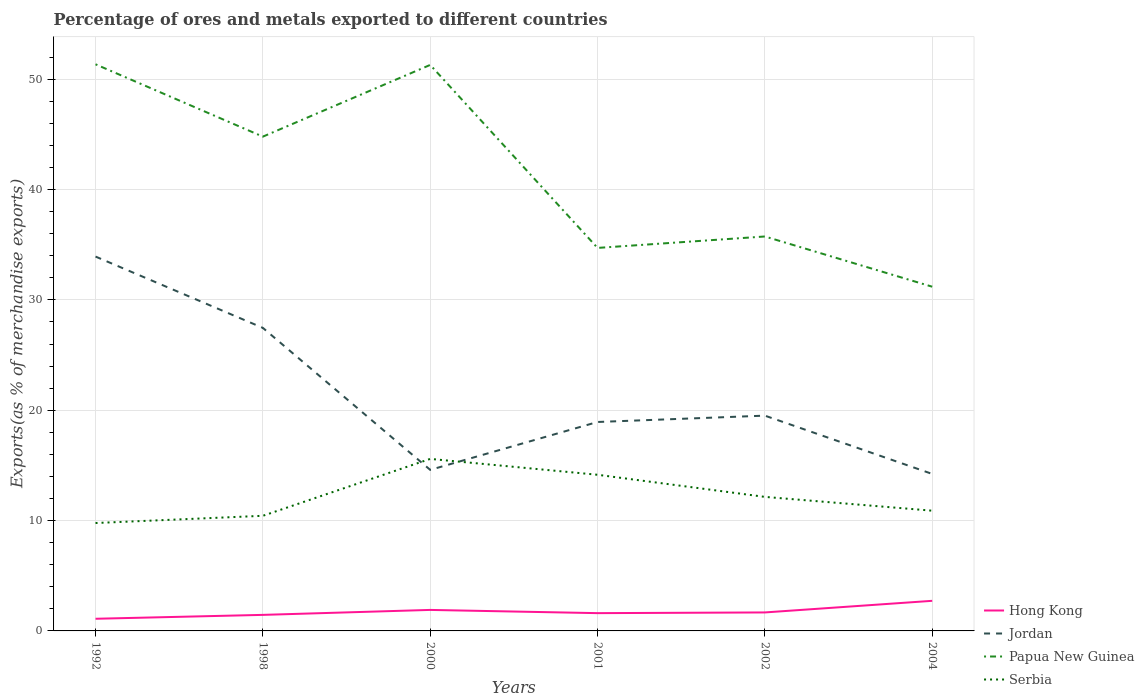How many different coloured lines are there?
Provide a short and direct response. 4. Across all years, what is the maximum percentage of exports to different countries in Papua New Guinea?
Keep it short and to the point. 31.2. In which year was the percentage of exports to different countries in Hong Kong maximum?
Offer a very short reply. 1992. What is the total percentage of exports to different countries in Jordan in the graph?
Offer a very short reply. 0.37. What is the difference between the highest and the second highest percentage of exports to different countries in Jordan?
Your response must be concise. 19.7. What is the difference between the highest and the lowest percentage of exports to different countries in Papua New Guinea?
Offer a very short reply. 3. How many lines are there?
Give a very brief answer. 4. Are the values on the major ticks of Y-axis written in scientific E-notation?
Make the answer very short. No. Does the graph contain any zero values?
Make the answer very short. No. Does the graph contain grids?
Your response must be concise. Yes. Where does the legend appear in the graph?
Offer a very short reply. Bottom right. How are the legend labels stacked?
Make the answer very short. Vertical. What is the title of the graph?
Your response must be concise. Percentage of ores and metals exported to different countries. What is the label or title of the X-axis?
Ensure brevity in your answer.  Years. What is the label or title of the Y-axis?
Offer a terse response. Exports(as % of merchandise exports). What is the Exports(as % of merchandise exports) in Hong Kong in 1992?
Keep it short and to the point. 1.1. What is the Exports(as % of merchandise exports) of Jordan in 1992?
Offer a terse response. 33.93. What is the Exports(as % of merchandise exports) of Papua New Guinea in 1992?
Offer a terse response. 51.36. What is the Exports(as % of merchandise exports) in Serbia in 1992?
Your answer should be compact. 9.78. What is the Exports(as % of merchandise exports) in Hong Kong in 1998?
Your response must be concise. 1.45. What is the Exports(as % of merchandise exports) of Jordan in 1998?
Your response must be concise. 27.46. What is the Exports(as % of merchandise exports) of Papua New Guinea in 1998?
Offer a terse response. 44.8. What is the Exports(as % of merchandise exports) in Serbia in 1998?
Keep it short and to the point. 10.43. What is the Exports(as % of merchandise exports) in Hong Kong in 2000?
Provide a succinct answer. 1.9. What is the Exports(as % of merchandise exports) in Jordan in 2000?
Keep it short and to the point. 14.6. What is the Exports(as % of merchandise exports) in Papua New Guinea in 2000?
Provide a short and direct response. 51.3. What is the Exports(as % of merchandise exports) in Serbia in 2000?
Your response must be concise. 15.59. What is the Exports(as % of merchandise exports) of Hong Kong in 2001?
Your answer should be compact. 1.61. What is the Exports(as % of merchandise exports) of Jordan in 2001?
Offer a very short reply. 18.94. What is the Exports(as % of merchandise exports) of Papua New Guinea in 2001?
Give a very brief answer. 34.71. What is the Exports(as % of merchandise exports) in Serbia in 2001?
Provide a short and direct response. 14.15. What is the Exports(as % of merchandise exports) in Hong Kong in 2002?
Keep it short and to the point. 1.67. What is the Exports(as % of merchandise exports) of Jordan in 2002?
Your answer should be compact. 19.51. What is the Exports(as % of merchandise exports) of Papua New Guinea in 2002?
Provide a short and direct response. 35.75. What is the Exports(as % of merchandise exports) in Serbia in 2002?
Make the answer very short. 12.15. What is the Exports(as % of merchandise exports) of Hong Kong in 2004?
Your answer should be compact. 2.73. What is the Exports(as % of merchandise exports) of Jordan in 2004?
Ensure brevity in your answer.  14.23. What is the Exports(as % of merchandise exports) of Papua New Guinea in 2004?
Make the answer very short. 31.2. What is the Exports(as % of merchandise exports) in Serbia in 2004?
Your answer should be compact. 10.9. Across all years, what is the maximum Exports(as % of merchandise exports) of Hong Kong?
Offer a terse response. 2.73. Across all years, what is the maximum Exports(as % of merchandise exports) in Jordan?
Provide a succinct answer. 33.93. Across all years, what is the maximum Exports(as % of merchandise exports) of Papua New Guinea?
Keep it short and to the point. 51.36. Across all years, what is the maximum Exports(as % of merchandise exports) in Serbia?
Offer a terse response. 15.59. Across all years, what is the minimum Exports(as % of merchandise exports) of Hong Kong?
Make the answer very short. 1.1. Across all years, what is the minimum Exports(as % of merchandise exports) of Jordan?
Keep it short and to the point. 14.23. Across all years, what is the minimum Exports(as % of merchandise exports) of Papua New Guinea?
Provide a succinct answer. 31.2. Across all years, what is the minimum Exports(as % of merchandise exports) of Serbia?
Ensure brevity in your answer.  9.78. What is the total Exports(as % of merchandise exports) in Hong Kong in the graph?
Your response must be concise. 10.47. What is the total Exports(as % of merchandise exports) of Jordan in the graph?
Give a very brief answer. 128.67. What is the total Exports(as % of merchandise exports) of Papua New Guinea in the graph?
Your response must be concise. 249.11. What is the total Exports(as % of merchandise exports) of Serbia in the graph?
Your answer should be compact. 73. What is the difference between the Exports(as % of merchandise exports) of Hong Kong in 1992 and that in 1998?
Make the answer very short. -0.35. What is the difference between the Exports(as % of merchandise exports) in Jordan in 1992 and that in 1998?
Your answer should be compact. 6.46. What is the difference between the Exports(as % of merchandise exports) of Papua New Guinea in 1992 and that in 1998?
Your response must be concise. 6.56. What is the difference between the Exports(as % of merchandise exports) in Serbia in 1992 and that in 1998?
Provide a short and direct response. -0.66. What is the difference between the Exports(as % of merchandise exports) of Hong Kong in 1992 and that in 2000?
Make the answer very short. -0.8. What is the difference between the Exports(as % of merchandise exports) of Jordan in 1992 and that in 2000?
Your answer should be compact. 19.33. What is the difference between the Exports(as % of merchandise exports) of Papua New Guinea in 1992 and that in 2000?
Offer a terse response. 0.06. What is the difference between the Exports(as % of merchandise exports) of Serbia in 1992 and that in 2000?
Offer a very short reply. -5.81. What is the difference between the Exports(as % of merchandise exports) in Hong Kong in 1992 and that in 2001?
Your answer should be very brief. -0.51. What is the difference between the Exports(as % of merchandise exports) in Jordan in 1992 and that in 2001?
Give a very brief answer. 14.99. What is the difference between the Exports(as % of merchandise exports) in Papua New Guinea in 1992 and that in 2001?
Make the answer very short. 16.64. What is the difference between the Exports(as % of merchandise exports) in Serbia in 1992 and that in 2001?
Your response must be concise. -4.37. What is the difference between the Exports(as % of merchandise exports) of Hong Kong in 1992 and that in 2002?
Your response must be concise. -0.57. What is the difference between the Exports(as % of merchandise exports) in Jordan in 1992 and that in 2002?
Your answer should be compact. 14.42. What is the difference between the Exports(as % of merchandise exports) of Papua New Guinea in 1992 and that in 2002?
Make the answer very short. 15.61. What is the difference between the Exports(as % of merchandise exports) in Serbia in 1992 and that in 2002?
Offer a very short reply. -2.37. What is the difference between the Exports(as % of merchandise exports) in Hong Kong in 1992 and that in 2004?
Keep it short and to the point. -1.63. What is the difference between the Exports(as % of merchandise exports) in Jordan in 1992 and that in 2004?
Give a very brief answer. 19.7. What is the difference between the Exports(as % of merchandise exports) of Papua New Guinea in 1992 and that in 2004?
Make the answer very short. 20.16. What is the difference between the Exports(as % of merchandise exports) in Serbia in 1992 and that in 2004?
Your answer should be compact. -1.12. What is the difference between the Exports(as % of merchandise exports) in Hong Kong in 1998 and that in 2000?
Give a very brief answer. -0.45. What is the difference between the Exports(as % of merchandise exports) in Jordan in 1998 and that in 2000?
Ensure brevity in your answer.  12.87. What is the difference between the Exports(as % of merchandise exports) of Papua New Guinea in 1998 and that in 2000?
Provide a succinct answer. -6.5. What is the difference between the Exports(as % of merchandise exports) of Serbia in 1998 and that in 2000?
Offer a very short reply. -5.16. What is the difference between the Exports(as % of merchandise exports) in Hong Kong in 1998 and that in 2001?
Give a very brief answer. -0.16. What is the difference between the Exports(as % of merchandise exports) in Jordan in 1998 and that in 2001?
Provide a succinct answer. 8.53. What is the difference between the Exports(as % of merchandise exports) of Papua New Guinea in 1998 and that in 2001?
Offer a terse response. 10.09. What is the difference between the Exports(as % of merchandise exports) in Serbia in 1998 and that in 2001?
Your answer should be compact. -3.72. What is the difference between the Exports(as % of merchandise exports) of Hong Kong in 1998 and that in 2002?
Make the answer very short. -0.22. What is the difference between the Exports(as % of merchandise exports) in Jordan in 1998 and that in 2002?
Provide a succinct answer. 7.95. What is the difference between the Exports(as % of merchandise exports) in Papua New Guinea in 1998 and that in 2002?
Provide a short and direct response. 9.05. What is the difference between the Exports(as % of merchandise exports) of Serbia in 1998 and that in 2002?
Keep it short and to the point. -1.71. What is the difference between the Exports(as % of merchandise exports) of Hong Kong in 1998 and that in 2004?
Your answer should be compact. -1.27. What is the difference between the Exports(as % of merchandise exports) in Jordan in 1998 and that in 2004?
Your answer should be very brief. 13.24. What is the difference between the Exports(as % of merchandise exports) in Papua New Guinea in 1998 and that in 2004?
Your answer should be compact. 13.6. What is the difference between the Exports(as % of merchandise exports) in Serbia in 1998 and that in 2004?
Make the answer very short. -0.46. What is the difference between the Exports(as % of merchandise exports) of Hong Kong in 2000 and that in 2001?
Make the answer very short. 0.29. What is the difference between the Exports(as % of merchandise exports) in Jordan in 2000 and that in 2001?
Your response must be concise. -4.34. What is the difference between the Exports(as % of merchandise exports) of Papua New Guinea in 2000 and that in 2001?
Provide a short and direct response. 16.59. What is the difference between the Exports(as % of merchandise exports) of Serbia in 2000 and that in 2001?
Offer a terse response. 1.44. What is the difference between the Exports(as % of merchandise exports) of Hong Kong in 2000 and that in 2002?
Give a very brief answer. 0.23. What is the difference between the Exports(as % of merchandise exports) in Jordan in 2000 and that in 2002?
Offer a very short reply. -4.91. What is the difference between the Exports(as % of merchandise exports) in Papua New Guinea in 2000 and that in 2002?
Offer a terse response. 15.55. What is the difference between the Exports(as % of merchandise exports) of Serbia in 2000 and that in 2002?
Keep it short and to the point. 3.44. What is the difference between the Exports(as % of merchandise exports) of Hong Kong in 2000 and that in 2004?
Your response must be concise. -0.82. What is the difference between the Exports(as % of merchandise exports) of Jordan in 2000 and that in 2004?
Provide a short and direct response. 0.37. What is the difference between the Exports(as % of merchandise exports) in Papua New Guinea in 2000 and that in 2004?
Give a very brief answer. 20.1. What is the difference between the Exports(as % of merchandise exports) of Serbia in 2000 and that in 2004?
Ensure brevity in your answer.  4.69. What is the difference between the Exports(as % of merchandise exports) of Hong Kong in 2001 and that in 2002?
Provide a succinct answer. -0.06. What is the difference between the Exports(as % of merchandise exports) of Jordan in 2001 and that in 2002?
Ensure brevity in your answer.  -0.57. What is the difference between the Exports(as % of merchandise exports) of Papua New Guinea in 2001 and that in 2002?
Ensure brevity in your answer.  -1.04. What is the difference between the Exports(as % of merchandise exports) in Serbia in 2001 and that in 2002?
Keep it short and to the point. 2.01. What is the difference between the Exports(as % of merchandise exports) in Hong Kong in 2001 and that in 2004?
Make the answer very short. -1.12. What is the difference between the Exports(as % of merchandise exports) of Jordan in 2001 and that in 2004?
Offer a terse response. 4.71. What is the difference between the Exports(as % of merchandise exports) of Papua New Guinea in 2001 and that in 2004?
Your response must be concise. 3.52. What is the difference between the Exports(as % of merchandise exports) in Serbia in 2001 and that in 2004?
Give a very brief answer. 3.26. What is the difference between the Exports(as % of merchandise exports) of Hong Kong in 2002 and that in 2004?
Offer a very short reply. -1.05. What is the difference between the Exports(as % of merchandise exports) in Jordan in 2002 and that in 2004?
Give a very brief answer. 5.28. What is the difference between the Exports(as % of merchandise exports) of Papua New Guinea in 2002 and that in 2004?
Offer a terse response. 4.55. What is the difference between the Exports(as % of merchandise exports) in Serbia in 2002 and that in 2004?
Give a very brief answer. 1.25. What is the difference between the Exports(as % of merchandise exports) in Hong Kong in 1992 and the Exports(as % of merchandise exports) in Jordan in 1998?
Offer a terse response. -26.36. What is the difference between the Exports(as % of merchandise exports) of Hong Kong in 1992 and the Exports(as % of merchandise exports) of Papua New Guinea in 1998?
Make the answer very short. -43.7. What is the difference between the Exports(as % of merchandise exports) of Hong Kong in 1992 and the Exports(as % of merchandise exports) of Serbia in 1998?
Provide a succinct answer. -9.33. What is the difference between the Exports(as % of merchandise exports) of Jordan in 1992 and the Exports(as % of merchandise exports) of Papua New Guinea in 1998?
Your response must be concise. -10.87. What is the difference between the Exports(as % of merchandise exports) in Jordan in 1992 and the Exports(as % of merchandise exports) in Serbia in 1998?
Provide a short and direct response. 23.49. What is the difference between the Exports(as % of merchandise exports) in Papua New Guinea in 1992 and the Exports(as % of merchandise exports) in Serbia in 1998?
Provide a succinct answer. 40.92. What is the difference between the Exports(as % of merchandise exports) in Hong Kong in 1992 and the Exports(as % of merchandise exports) in Jordan in 2000?
Provide a short and direct response. -13.5. What is the difference between the Exports(as % of merchandise exports) in Hong Kong in 1992 and the Exports(as % of merchandise exports) in Papua New Guinea in 2000?
Provide a short and direct response. -50.2. What is the difference between the Exports(as % of merchandise exports) in Hong Kong in 1992 and the Exports(as % of merchandise exports) in Serbia in 2000?
Make the answer very short. -14.49. What is the difference between the Exports(as % of merchandise exports) in Jordan in 1992 and the Exports(as % of merchandise exports) in Papua New Guinea in 2000?
Provide a succinct answer. -17.37. What is the difference between the Exports(as % of merchandise exports) in Jordan in 1992 and the Exports(as % of merchandise exports) in Serbia in 2000?
Provide a short and direct response. 18.34. What is the difference between the Exports(as % of merchandise exports) in Papua New Guinea in 1992 and the Exports(as % of merchandise exports) in Serbia in 2000?
Your response must be concise. 35.76. What is the difference between the Exports(as % of merchandise exports) of Hong Kong in 1992 and the Exports(as % of merchandise exports) of Jordan in 2001?
Your answer should be compact. -17.83. What is the difference between the Exports(as % of merchandise exports) in Hong Kong in 1992 and the Exports(as % of merchandise exports) in Papua New Guinea in 2001?
Offer a very short reply. -33.61. What is the difference between the Exports(as % of merchandise exports) in Hong Kong in 1992 and the Exports(as % of merchandise exports) in Serbia in 2001?
Offer a terse response. -13.05. What is the difference between the Exports(as % of merchandise exports) of Jordan in 1992 and the Exports(as % of merchandise exports) of Papua New Guinea in 2001?
Ensure brevity in your answer.  -0.79. What is the difference between the Exports(as % of merchandise exports) in Jordan in 1992 and the Exports(as % of merchandise exports) in Serbia in 2001?
Provide a succinct answer. 19.78. What is the difference between the Exports(as % of merchandise exports) of Papua New Guinea in 1992 and the Exports(as % of merchandise exports) of Serbia in 2001?
Keep it short and to the point. 37.2. What is the difference between the Exports(as % of merchandise exports) in Hong Kong in 1992 and the Exports(as % of merchandise exports) in Jordan in 2002?
Your answer should be very brief. -18.41. What is the difference between the Exports(as % of merchandise exports) of Hong Kong in 1992 and the Exports(as % of merchandise exports) of Papua New Guinea in 2002?
Your response must be concise. -34.65. What is the difference between the Exports(as % of merchandise exports) in Hong Kong in 1992 and the Exports(as % of merchandise exports) in Serbia in 2002?
Make the answer very short. -11.05. What is the difference between the Exports(as % of merchandise exports) in Jordan in 1992 and the Exports(as % of merchandise exports) in Papua New Guinea in 2002?
Give a very brief answer. -1.82. What is the difference between the Exports(as % of merchandise exports) of Jordan in 1992 and the Exports(as % of merchandise exports) of Serbia in 2002?
Your response must be concise. 21.78. What is the difference between the Exports(as % of merchandise exports) of Papua New Guinea in 1992 and the Exports(as % of merchandise exports) of Serbia in 2002?
Ensure brevity in your answer.  39.21. What is the difference between the Exports(as % of merchandise exports) in Hong Kong in 1992 and the Exports(as % of merchandise exports) in Jordan in 2004?
Give a very brief answer. -13.13. What is the difference between the Exports(as % of merchandise exports) of Hong Kong in 1992 and the Exports(as % of merchandise exports) of Papua New Guinea in 2004?
Offer a terse response. -30.1. What is the difference between the Exports(as % of merchandise exports) in Hong Kong in 1992 and the Exports(as % of merchandise exports) in Serbia in 2004?
Offer a terse response. -9.8. What is the difference between the Exports(as % of merchandise exports) of Jordan in 1992 and the Exports(as % of merchandise exports) of Papua New Guinea in 2004?
Your answer should be very brief. 2.73. What is the difference between the Exports(as % of merchandise exports) of Jordan in 1992 and the Exports(as % of merchandise exports) of Serbia in 2004?
Make the answer very short. 23.03. What is the difference between the Exports(as % of merchandise exports) of Papua New Guinea in 1992 and the Exports(as % of merchandise exports) of Serbia in 2004?
Make the answer very short. 40.46. What is the difference between the Exports(as % of merchandise exports) in Hong Kong in 1998 and the Exports(as % of merchandise exports) in Jordan in 2000?
Your response must be concise. -13.14. What is the difference between the Exports(as % of merchandise exports) of Hong Kong in 1998 and the Exports(as % of merchandise exports) of Papua New Guinea in 2000?
Ensure brevity in your answer.  -49.85. What is the difference between the Exports(as % of merchandise exports) of Hong Kong in 1998 and the Exports(as % of merchandise exports) of Serbia in 2000?
Keep it short and to the point. -14.14. What is the difference between the Exports(as % of merchandise exports) in Jordan in 1998 and the Exports(as % of merchandise exports) in Papua New Guinea in 2000?
Offer a terse response. -23.83. What is the difference between the Exports(as % of merchandise exports) in Jordan in 1998 and the Exports(as % of merchandise exports) in Serbia in 2000?
Provide a succinct answer. 11.87. What is the difference between the Exports(as % of merchandise exports) of Papua New Guinea in 1998 and the Exports(as % of merchandise exports) of Serbia in 2000?
Your answer should be very brief. 29.21. What is the difference between the Exports(as % of merchandise exports) in Hong Kong in 1998 and the Exports(as % of merchandise exports) in Jordan in 2001?
Ensure brevity in your answer.  -17.48. What is the difference between the Exports(as % of merchandise exports) of Hong Kong in 1998 and the Exports(as % of merchandise exports) of Papua New Guinea in 2001?
Your response must be concise. -33.26. What is the difference between the Exports(as % of merchandise exports) in Hong Kong in 1998 and the Exports(as % of merchandise exports) in Serbia in 2001?
Your answer should be compact. -12.7. What is the difference between the Exports(as % of merchandise exports) of Jordan in 1998 and the Exports(as % of merchandise exports) of Papua New Guinea in 2001?
Make the answer very short. -7.25. What is the difference between the Exports(as % of merchandise exports) in Jordan in 1998 and the Exports(as % of merchandise exports) in Serbia in 2001?
Make the answer very short. 13.31. What is the difference between the Exports(as % of merchandise exports) in Papua New Guinea in 1998 and the Exports(as % of merchandise exports) in Serbia in 2001?
Give a very brief answer. 30.65. What is the difference between the Exports(as % of merchandise exports) of Hong Kong in 1998 and the Exports(as % of merchandise exports) of Jordan in 2002?
Provide a short and direct response. -18.06. What is the difference between the Exports(as % of merchandise exports) of Hong Kong in 1998 and the Exports(as % of merchandise exports) of Papua New Guinea in 2002?
Your answer should be very brief. -34.3. What is the difference between the Exports(as % of merchandise exports) in Hong Kong in 1998 and the Exports(as % of merchandise exports) in Serbia in 2002?
Keep it short and to the point. -10.69. What is the difference between the Exports(as % of merchandise exports) of Jordan in 1998 and the Exports(as % of merchandise exports) of Papua New Guinea in 2002?
Give a very brief answer. -8.28. What is the difference between the Exports(as % of merchandise exports) in Jordan in 1998 and the Exports(as % of merchandise exports) in Serbia in 2002?
Your answer should be very brief. 15.32. What is the difference between the Exports(as % of merchandise exports) of Papua New Guinea in 1998 and the Exports(as % of merchandise exports) of Serbia in 2002?
Ensure brevity in your answer.  32.65. What is the difference between the Exports(as % of merchandise exports) in Hong Kong in 1998 and the Exports(as % of merchandise exports) in Jordan in 2004?
Your answer should be very brief. -12.78. What is the difference between the Exports(as % of merchandise exports) in Hong Kong in 1998 and the Exports(as % of merchandise exports) in Papua New Guinea in 2004?
Make the answer very short. -29.74. What is the difference between the Exports(as % of merchandise exports) of Hong Kong in 1998 and the Exports(as % of merchandise exports) of Serbia in 2004?
Make the answer very short. -9.44. What is the difference between the Exports(as % of merchandise exports) in Jordan in 1998 and the Exports(as % of merchandise exports) in Papua New Guinea in 2004?
Offer a very short reply. -3.73. What is the difference between the Exports(as % of merchandise exports) in Jordan in 1998 and the Exports(as % of merchandise exports) in Serbia in 2004?
Keep it short and to the point. 16.57. What is the difference between the Exports(as % of merchandise exports) in Papua New Guinea in 1998 and the Exports(as % of merchandise exports) in Serbia in 2004?
Give a very brief answer. 33.9. What is the difference between the Exports(as % of merchandise exports) of Hong Kong in 2000 and the Exports(as % of merchandise exports) of Jordan in 2001?
Give a very brief answer. -17.03. What is the difference between the Exports(as % of merchandise exports) in Hong Kong in 2000 and the Exports(as % of merchandise exports) in Papua New Guinea in 2001?
Give a very brief answer. -32.81. What is the difference between the Exports(as % of merchandise exports) of Hong Kong in 2000 and the Exports(as % of merchandise exports) of Serbia in 2001?
Offer a terse response. -12.25. What is the difference between the Exports(as % of merchandise exports) in Jordan in 2000 and the Exports(as % of merchandise exports) in Papua New Guinea in 2001?
Provide a short and direct response. -20.12. What is the difference between the Exports(as % of merchandise exports) in Jordan in 2000 and the Exports(as % of merchandise exports) in Serbia in 2001?
Offer a terse response. 0.44. What is the difference between the Exports(as % of merchandise exports) of Papua New Guinea in 2000 and the Exports(as % of merchandise exports) of Serbia in 2001?
Make the answer very short. 37.15. What is the difference between the Exports(as % of merchandise exports) of Hong Kong in 2000 and the Exports(as % of merchandise exports) of Jordan in 2002?
Your answer should be very brief. -17.61. What is the difference between the Exports(as % of merchandise exports) of Hong Kong in 2000 and the Exports(as % of merchandise exports) of Papua New Guinea in 2002?
Ensure brevity in your answer.  -33.85. What is the difference between the Exports(as % of merchandise exports) in Hong Kong in 2000 and the Exports(as % of merchandise exports) in Serbia in 2002?
Your response must be concise. -10.24. What is the difference between the Exports(as % of merchandise exports) in Jordan in 2000 and the Exports(as % of merchandise exports) in Papua New Guinea in 2002?
Offer a very short reply. -21.15. What is the difference between the Exports(as % of merchandise exports) of Jordan in 2000 and the Exports(as % of merchandise exports) of Serbia in 2002?
Provide a succinct answer. 2.45. What is the difference between the Exports(as % of merchandise exports) in Papua New Guinea in 2000 and the Exports(as % of merchandise exports) in Serbia in 2002?
Your answer should be very brief. 39.15. What is the difference between the Exports(as % of merchandise exports) of Hong Kong in 2000 and the Exports(as % of merchandise exports) of Jordan in 2004?
Provide a succinct answer. -12.33. What is the difference between the Exports(as % of merchandise exports) of Hong Kong in 2000 and the Exports(as % of merchandise exports) of Papua New Guinea in 2004?
Provide a succinct answer. -29.29. What is the difference between the Exports(as % of merchandise exports) of Hong Kong in 2000 and the Exports(as % of merchandise exports) of Serbia in 2004?
Provide a short and direct response. -8.99. What is the difference between the Exports(as % of merchandise exports) in Jordan in 2000 and the Exports(as % of merchandise exports) in Papua New Guinea in 2004?
Offer a terse response. -16.6. What is the difference between the Exports(as % of merchandise exports) of Jordan in 2000 and the Exports(as % of merchandise exports) of Serbia in 2004?
Provide a succinct answer. 3.7. What is the difference between the Exports(as % of merchandise exports) of Papua New Guinea in 2000 and the Exports(as % of merchandise exports) of Serbia in 2004?
Keep it short and to the point. 40.4. What is the difference between the Exports(as % of merchandise exports) of Hong Kong in 2001 and the Exports(as % of merchandise exports) of Jordan in 2002?
Provide a short and direct response. -17.9. What is the difference between the Exports(as % of merchandise exports) of Hong Kong in 2001 and the Exports(as % of merchandise exports) of Papua New Guinea in 2002?
Your answer should be compact. -34.14. What is the difference between the Exports(as % of merchandise exports) of Hong Kong in 2001 and the Exports(as % of merchandise exports) of Serbia in 2002?
Your response must be concise. -10.54. What is the difference between the Exports(as % of merchandise exports) in Jordan in 2001 and the Exports(as % of merchandise exports) in Papua New Guinea in 2002?
Your answer should be compact. -16.81. What is the difference between the Exports(as % of merchandise exports) in Jordan in 2001 and the Exports(as % of merchandise exports) in Serbia in 2002?
Your answer should be very brief. 6.79. What is the difference between the Exports(as % of merchandise exports) of Papua New Guinea in 2001 and the Exports(as % of merchandise exports) of Serbia in 2002?
Your answer should be very brief. 22.57. What is the difference between the Exports(as % of merchandise exports) in Hong Kong in 2001 and the Exports(as % of merchandise exports) in Jordan in 2004?
Make the answer very short. -12.62. What is the difference between the Exports(as % of merchandise exports) of Hong Kong in 2001 and the Exports(as % of merchandise exports) of Papua New Guinea in 2004?
Offer a terse response. -29.59. What is the difference between the Exports(as % of merchandise exports) of Hong Kong in 2001 and the Exports(as % of merchandise exports) of Serbia in 2004?
Keep it short and to the point. -9.28. What is the difference between the Exports(as % of merchandise exports) in Jordan in 2001 and the Exports(as % of merchandise exports) in Papua New Guinea in 2004?
Your answer should be compact. -12.26. What is the difference between the Exports(as % of merchandise exports) in Jordan in 2001 and the Exports(as % of merchandise exports) in Serbia in 2004?
Make the answer very short. 8.04. What is the difference between the Exports(as % of merchandise exports) in Papua New Guinea in 2001 and the Exports(as % of merchandise exports) in Serbia in 2004?
Provide a succinct answer. 23.82. What is the difference between the Exports(as % of merchandise exports) in Hong Kong in 2002 and the Exports(as % of merchandise exports) in Jordan in 2004?
Give a very brief answer. -12.55. What is the difference between the Exports(as % of merchandise exports) in Hong Kong in 2002 and the Exports(as % of merchandise exports) in Papua New Guinea in 2004?
Your response must be concise. -29.52. What is the difference between the Exports(as % of merchandise exports) of Hong Kong in 2002 and the Exports(as % of merchandise exports) of Serbia in 2004?
Your answer should be compact. -9.22. What is the difference between the Exports(as % of merchandise exports) of Jordan in 2002 and the Exports(as % of merchandise exports) of Papua New Guinea in 2004?
Your answer should be compact. -11.69. What is the difference between the Exports(as % of merchandise exports) in Jordan in 2002 and the Exports(as % of merchandise exports) in Serbia in 2004?
Make the answer very short. 8.61. What is the difference between the Exports(as % of merchandise exports) of Papua New Guinea in 2002 and the Exports(as % of merchandise exports) of Serbia in 2004?
Your answer should be compact. 24.85. What is the average Exports(as % of merchandise exports) of Hong Kong per year?
Make the answer very short. 1.75. What is the average Exports(as % of merchandise exports) in Jordan per year?
Offer a terse response. 21.44. What is the average Exports(as % of merchandise exports) in Papua New Guinea per year?
Give a very brief answer. 41.52. What is the average Exports(as % of merchandise exports) in Serbia per year?
Your answer should be very brief. 12.17. In the year 1992, what is the difference between the Exports(as % of merchandise exports) in Hong Kong and Exports(as % of merchandise exports) in Jordan?
Your response must be concise. -32.83. In the year 1992, what is the difference between the Exports(as % of merchandise exports) in Hong Kong and Exports(as % of merchandise exports) in Papua New Guinea?
Your answer should be compact. -50.25. In the year 1992, what is the difference between the Exports(as % of merchandise exports) of Hong Kong and Exports(as % of merchandise exports) of Serbia?
Your answer should be compact. -8.68. In the year 1992, what is the difference between the Exports(as % of merchandise exports) of Jordan and Exports(as % of merchandise exports) of Papua New Guinea?
Your answer should be compact. -17.43. In the year 1992, what is the difference between the Exports(as % of merchandise exports) of Jordan and Exports(as % of merchandise exports) of Serbia?
Keep it short and to the point. 24.15. In the year 1992, what is the difference between the Exports(as % of merchandise exports) of Papua New Guinea and Exports(as % of merchandise exports) of Serbia?
Give a very brief answer. 41.58. In the year 1998, what is the difference between the Exports(as % of merchandise exports) of Hong Kong and Exports(as % of merchandise exports) of Jordan?
Keep it short and to the point. -26.01. In the year 1998, what is the difference between the Exports(as % of merchandise exports) of Hong Kong and Exports(as % of merchandise exports) of Papua New Guinea?
Keep it short and to the point. -43.34. In the year 1998, what is the difference between the Exports(as % of merchandise exports) in Hong Kong and Exports(as % of merchandise exports) in Serbia?
Provide a short and direct response. -8.98. In the year 1998, what is the difference between the Exports(as % of merchandise exports) in Jordan and Exports(as % of merchandise exports) in Papua New Guinea?
Offer a terse response. -17.33. In the year 1998, what is the difference between the Exports(as % of merchandise exports) in Jordan and Exports(as % of merchandise exports) in Serbia?
Provide a succinct answer. 17.03. In the year 1998, what is the difference between the Exports(as % of merchandise exports) of Papua New Guinea and Exports(as % of merchandise exports) of Serbia?
Offer a very short reply. 34.36. In the year 2000, what is the difference between the Exports(as % of merchandise exports) in Hong Kong and Exports(as % of merchandise exports) in Jordan?
Make the answer very short. -12.69. In the year 2000, what is the difference between the Exports(as % of merchandise exports) of Hong Kong and Exports(as % of merchandise exports) of Papua New Guinea?
Offer a terse response. -49.4. In the year 2000, what is the difference between the Exports(as % of merchandise exports) of Hong Kong and Exports(as % of merchandise exports) of Serbia?
Offer a terse response. -13.69. In the year 2000, what is the difference between the Exports(as % of merchandise exports) of Jordan and Exports(as % of merchandise exports) of Papua New Guinea?
Give a very brief answer. -36.7. In the year 2000, what is the difference between the Exports(as % of merchandise exports) in Jordan and Exports(as % of merchandise exports) in Serbia?
Give a very brief answer. -0.99. In the year 2000, what is the difference between the Exports(as % of merchandise exports) of Papua New Guinea and Exports(as % of merchandise exports) of Serbia?
Your answer should be compact. 35.71. In the year 2001, what is the difference between the Exports(as % of merchandise exports) in Hong Kong and Exports(as % of merchandise exports) in Jordan?
Keep it short and to the point. -17.32. In the year 2001, what is the difference between the Exports(as % of merchandise exports) of Hong Kong and Exports(as % of merchandise exports) of Papua New Guinea?
Ensure brevity in your answer.  -33.1. In the year 2001, what is the difference between the Exports(as % of merchandise exports) of Hong Kong and Exports(as % of merchandise exports) of Serbia?
Offer a very short reply. -12.54. In the year 2001, what is the difference between the Exports(as % of merchandise exports) in Jordan and Exports(as % of merchandise exports) in Papua New Guinea?
Provide a succinct answer. -15.78. In the year 2001, what is the difference between the Exports(as % of merchandise exports) in Jordan and Exports(as % of merchandise exports) in Serbia?
Provide a succinct answer. 4.78. In the year 2001, what is the difference between the Exports(as % of merchandise exports) of Papua New Guinea and Exports(as % of merchandise exports) of Serbia?
Your answer should be very brief. 20.56. In the year 2002, what is the difference between the Exports(as % of merchandise exports) in Hong Kong and Exports(as % of merchandise exports) in Jordan?
Offer a terse response. -17.84. In the year 2002, what is the difference between the Exports(as % of merchandise exports) of Hong Kong and Exports(as % of merchandise exports) of Papua New Guinea?
Your response must be concise. -34.07. In the year 2002, what is the difference between the Exports(as % of merchandise exports) in Hong Kong and Exports(as % of merchandise exports) in Serbia?
Your response must be concise. -10.47. In the year 2002, what is the difference between the Exports(as % of merchandise exports) of Jordan and Exports(as % of merchandise exports) of Papua New Guinea?
Your answer should be very brief. -16.24. In the year 2002, what is the difference between the Exports(as % of merchandise exports) in Jordan and Exports(as % of merchandise exports) in Serbia?
Make the answer very short. 7.36. In the year 2002, what is the difference between the Exports(as % of merchandise exports) of Papua New Guinea and Exports(as % of merchandise exports) of Serbia?
Provide a short and direct response. 23.6. In the year 2004, what is the difference between the Exports(as % of merchandise exports) of Hong Kong and Exports(as % of merchandise exports) of Jordan?
Offer a very short reply. -11.5. In the year 2004, what is the difference between the Exports(as % of merchandise exports) in Hong Kong and Exports(as % of merchandise exports) in Papua New Guinea?
Give a very brief answer. -28.47. In the year 2004, what is the difference between the Exports(as % of merchandise exports) in Hong Kong and Exports(as % of merchandise exports) in Serbia?
Your response must be concise. -8.17. In the year 2004, what is the difference between the Exports(as % of merchandise exports) in Jordan and Exports(as % of merchandise exports) in Papua New Guinea?
Give a very brief answer. -16.97. In the year 2004, what is the difference between the Exports(as % of merchandise exports) in Jordan and Exports(as % of merchandise exports) in Serbia?
Offer a very short reply. 3.33. In the year 2004, what is the difference between the Exports(as % of merchandise exports) in Papua New Guinea and Exports(as % of merchandise exports) in Serbia?
Offer a terse response. 20.3. What is the ratio of the Exports(as % of merchandise exports) in Hong Kong in 1992 to that in 1998?
Your answer should be compact. 0.76. What is the ratio of the Exports(as % of merchandise exports) in Jordan in 1992 to that in 1998?
Keep it short and to the point. 1.24. What is the ratio of the Exports(as % of merchandise exports) in Papua New Guinea in 1992 to that in 1998?
Keep it short and to the point. 1.15. What is the ratio of the Exports(as % of merchandise exports) of Serbia in 1992 to that in 1998?
Make the answer very short. 0.94. What is the ratio of the Exports(as % of merchandise exports) of Hong Kong in 1992 to that in 2000?
Your response must be concise. 0.58. What is the ratio of the Exports(as % of merchandise exports) of Jordan in 1992 to that in 2000?
Make the answer very short. 2.32. What is the ratio of the Exports(as % of merchandise exports) of Serbia in 1992 to that in 2000?
Your response must be concise. 0.63. What is the ratio of the Exports(as % of merchandise exports) of Hong Kong in 1992 to that in 2001?
Your answer should be compact. 0.68. What is the ratio of the Exports(as % of merchandise exports) in Jordan in 1992 to that in 2001?
Keep it short and to the point. 1.79. What is the ratio of the Exports(as % of merchandise exports) in Papua New Guinea in 1992 to that in 2001?
Keep it short and to the point. 1.48. What is the ratio of the Exports(as % of merchandise exports) in Serbia in 1992 to that in 2001?
Your answer should be compact. 0.69. What is the ratio of the Exports(as % of merchandise exports) of Hong Kong in 1992 to that in 2002?
Ensure brevity in your answer.  0.66. What is the ratio of the Exports(as % of merchandise exports) of Jordan in 1992 to that in 2002?
Make the answer very short. 1.74. What is the ratio of the Exports(as % of merchandise exports) in Papua New Guinea in 1992 to that in 2002?
Ensure brevity in your answer.  1.44. What is the ratio of the Exports(as % of merchandise exports) in Serbia in 1992 to that in 2002?
Offer a terse response. 0.81. What is the ratio of the Exports(as % of merchandise exports) of Hong Kong in 1992 to that in 2004?
Your response must be concise. 0.4. What is the ratio of the Exports(as % of merchandise exports) of Jordan in 1992 to that in 2004?
Make the answer very short. 2.38. What is the ratio of the Exports(as % of merchandise exports) of Papua New Guinea in 1992 to that in 2004?
Your answer should be compact. 1.65. What is the ratio of the Exports(as % of merchandise exports) of Serbia in 1992 to that in 2004?
Make the answer very short. 0.9. What is the ratio of the Exports(as % of merchandise exports) in Hong Kong in 1998 to that in 2000?
Provide a succinct answer. 0.76. What is the ratio of the Exports(as % of merchandise exports) in Jordan in 1998 to that in 2000?
Ensure brevity in your answer.  1.88. What is the ratio of the Exports(as % of merchandise exports) of Papua New Guinea in 1998 to that in 2000?
Your answer should be very brief. 0.87. What is the ratio of the Exports(as % of merchandise exports) of Serbia in 1998 to that in 2000?
Give a very brief answer. 0.67. What is the ratio of the Exports(as % of merchandise exports) of Hong Kong in 1998 to that in 2001?
Provide a succinct answer. 0.9. What is the ratio of the Exports(as % of merchandise exports) in Jordan in 1998 to that in 2001?
Provide a succinct answer. 1.45. What is the ratio of the Exports(as % of merchandise exports) in Papua New Guinea in 1998 to that in 2001?
Make the answer very short. 1.29. What is the ratio of the Exports(as % of merchandise exports) of Serbia in 1998 to that in 2001?
Provide a short and direct response. 0.74. What is the ratio of the Exports(as % of merchandise exports) of Hong Kong in 1998 to that in 2002?
Provide a short and direct response. 0.87. What is the ratio of the Exports(as % of merchandise exports) of Jordan in 1998 to that in 2002?
Make the answer very short. 1.41. What is the ratio of the Exports(as % of merchandise exports) of Papua New Guinea in 1998 to that in 2002?
Keep it short and to the point. 1.25. What is the ratio of the Exports(as % of merchandise exports) of Serbia in 1998 to that in 2002?
Your answer should be very brief. 0.86. What is the ratio of the Exports(as % of merchandise exports) in Hong Kong in 1998 to that in 2004?
Your answer should be very brief. 0.53. What is the ratio of the Exports(as % of merchandise exports) of Jordan in 1998 to that in 2004?
Provide a succinct answer. 1.93. What is the ratio of the Exports(as % of merchandise exports) of Papua New Guinea in 1998 to that in 2004?
Your answer should be very brief. 1.44. What is the ratio of the Exports(as % of merchandise exports) in Serbia in 1998 to that in 2004?
Ensure brevity in your answer.  0.96. What is the ratio of the Exports(as % of merchandise exports) of Hong Kong in 2000 to that in 2001?
Provide a short and direct response. 1.18. What is the ratio of the Exports(as % of merchandise exports) of Jordan in 2000 to that in 2001?
Provide a short and direct response. 0.77. What is the ratio of the Exports(as % of merchandise exports) of Papua New Guinea in 2000 to that in 2001?
Your response must be concise. 1.48. What is the ratio of the Exports(as % of merchandise exports) of Serbia in 2000 to that in 2001?
Ensure brevity in your answer.  1.1. What is the ratio of the Exports(as % of merchandise exports) of Hong Kong in 2000 to that in 2002?
Give a very brief answer. 1.14. What is the ratio of the Exports(as % of merchandise exports) of Jordan in 2000 to that in 2002?
Offer a terse response. 0.75. What is the ratio of the Exports(as % of merchandise exports) of Papua New Guinea in 2000 to that in 2002?
Make the answer very short. 1.44. What is the ratio of the Exports(as % of merchandise exports) in Serbia in 2000 to that in 2002?
Your answer should be very brief. 1.28. What is the ratio of the Exports(as % of merchandise exports) in Hong Kong in 2000 to that in 2004?
Your response must be concise. 0.7. What is the ratio of the Exports(as % of merchandise exports) of Jordan in 2000 to that in 2004?
Offer a very short reply. 1.03. What is the ratio of the Exports(as % of merchandise exports) in Papua New Guinea in 2000 to that in 2004?
Provide a succinct answer. 1.64. What is the ratio of the Exports(as % of merchandise exports) of Serbia in 2000 to that in 2004?
Offer a terse response. 1.43. What is the ratio of the Exports(as % of merchandise exports) of Hong Kong in 2001 to that in 2002?
Keep it short and to the point. 0.96. What is the ratio of the Exports(as % of merchandise exports) of Jordan in 2001 to that in 2002?
Give a very brief answer. 0.97. What is the ratio of the Exports(as % of merchandise exports) in Serbia in 2001 to that in 2002?
Your response must be concise. 1.17. What is the ratio of the Exports(as % of merchandise exports) of Hong Kong in 2001 to that in 2004?
Give a very brief answer. 0.59. What is the ratio of the Exports(as % of merchandise exports) in Jordan in 2001 to that in 2004?
Your response must be concise. 1.33. What is the ratio of the Exports(as % of merchandise exports) of Papua New Guinea in 2001 to that in 2004?
Give a very brief answer. 1.11. What is the ratio of the Exports(as % of merchandise exports) in Serbia in 2001 to that in 2004?
Your answer should be compact. 1.3. What is the ratio of the Exports(as % of merchandise exports) in Hong Kong in 2002 to that in 2004?
Your answer should be very brief. 0.61. What is the ratio of the Exports(as % of merchandise exports) in Jordan in 2002 to that in 2004?
Provide a short and direct response. 1.37. What is the ratio of the Exports(as % of merchandise exports) of Papua New Guinea in 2002 to that in 2004?
Your response must be concise. 1.15. What is the ratio of the Exports(as % of merchandise exports) of Serbia in 2002 to that in 2004?
Your response must be concise. 1.11. What is the difference between the highest and the second highest Exports(as % of merchandise exports) of Hong Kong?
Your answer should be compact. 0.82. What is the difference between the highest and the second highest Exports(as % of merchandise exports) of Jordan?
Provide a short and direct response. 6.46. What is the difference between the highest and the second highest Exports(as % of merchandise exports) in Papua New Guinea?
Your answer should be compact. 0.06. What is the difference between the highest and the second highest Exports(as % of merchandise exports) in Serbia?
Make the answer very short. 1.44. What is the difference between the highest and the lowest Exports(as % of merchandise exports) of Hong Kong?
Your answer should be compact. 1.63. What is the difference between the highest and the lowest Exports(as % of merchandise exports) in Jordan?
Offer a terse response. 19.7. What is the difference between the highest and the lowest Exports(as % of merchandise exports) of Papua New Guinea?
Your answer should be very brief. 20.16. What is the difference between the highest and the lowest Exports(as % of merchandise exports) in Serbia?
Offer a terse response. 5.81. 